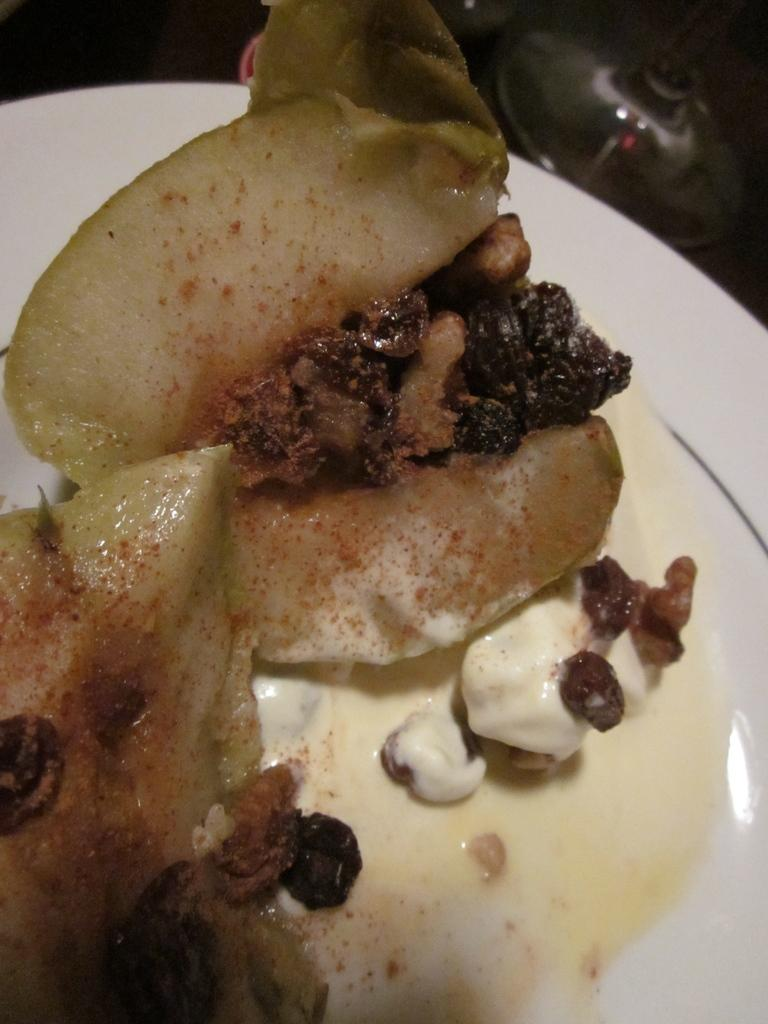What is on the plate that is visible in the image? There is food on a plate in the image. What else can be seen in the image besides the plate of food? There are other objects visible in the top right corner of the image. Is there a root growing out of the food on the plate in the image? No, there is no root growing out of the food on the plate in the image. Is there an umbrella visible in the image? The provided facts do not mention an umbrella, so we cannot determine if one is visible in the image. 